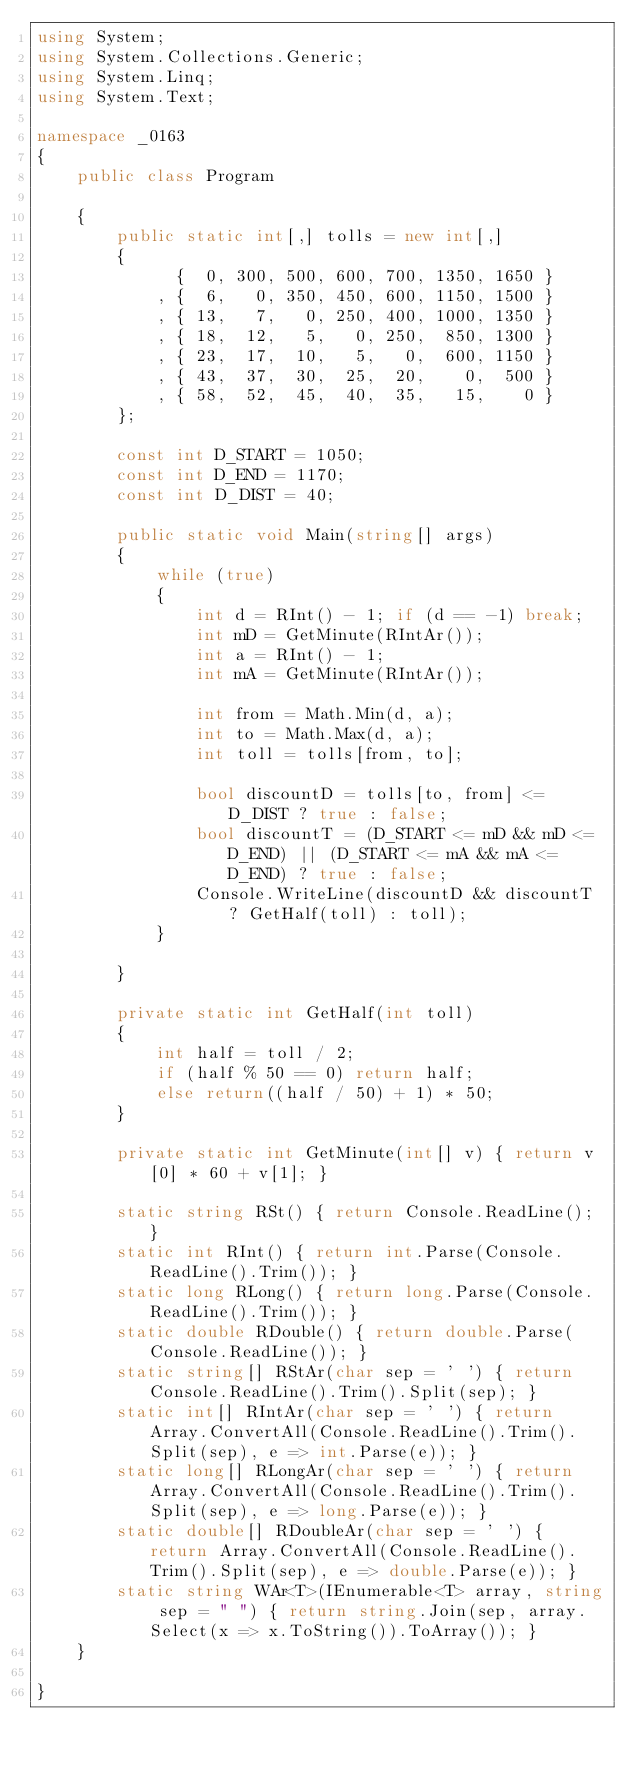<code> <loc_0><loc_0><loc_500><loc_500><_C#_>using System;
using System.Collections.Generic;
using System.Linq;
using System.Text;

namespace _0163
{
    public class Program

    {
        public static int[,] tolls = new int[,]
        {
              {  0, 300, 500, 600, 700, 1350, 1650 }
            , {  6,   0, 350, 450, 600, 1150, 1500 }
            , { 13,   7,   0, 250, 400, 1000, 1350 }
            , { 18,  12,   5,   0, 250,  850, 1300 }
            , { 23,  17,  10,   5,   0,  600, 1150 }
            , { 43,  37,  30,  25,  20,    0,  500 }
            , { 58,  52,  45,  40,  35,   15,    0 }
        };

        const int D_START = 1050;
        const int D_END = 1170;
        const int D_DIST = 40;

        public static void Main(string[] args)
        {
            while (true)
            {
                int d = RInt() - 1; if (d == -1) break;
                int mD = GetMinute(RIntAr());
                int a = RInt() - 1;
                int mA = GetMinute(RIntAr());

                int from = Math.Min(d, a);
                int to = Math.Max(d, a);
                int toll = tolls[from, to];

                bool discountD = tolls[to, from] <= D_DIST ? true : false;
                bool discountT = (D_START <= mD && mD <= D_END) || (D_START <= mA && mA <= D_END) ? true : false;
                Console.WriteLine(discountD && discountT ? GetHalf(toll) : toll);
            }

        }

        private static int GetHalf(int toll)
        {
            int half = toll / 2;
            if (half % 50 == 0) return half;
            else return((half / 50) + 1) * 50;
        }

        private static int GetMinute(int[] v) { return v[0] * 60 + v[1]; }

        static string RSt() { return Console.ReadLine(); }
        static int RInt() { return int.Parse(Console.ReadLine().Trim()); }
        static long RLong() { return long.Parse(Console.ReadLine().Trim()); }
        static double RDouble() { return double.Parse(Console.ReadLine()); }
        static string[] RStAr(char sep = ' ') { return Console.ReadLine().Trim().Split(sep); }
        static int[] RIntAr(char sep = ' ') { return Array.ConvertAll(Console.ReadLine().Trim().Split(sep), e => int.Parse(e)); }
        static long[] RLongAr(char sep = ' ') { return Array.ConvertAll(Console.ReadLine().Trim().Split(sep), e => long.Parse(e)); }
        static double[] RDoubleAr(char sep = ' ') { return Array.ConvertAll(Console.ReadLine().Trim().Split(sep), e => double.Parse(e)); }
        static string WAr<T>(IEnumerable<T> array, string sep = " ") { return string.Join(sep, array.Select(x => x.ToString()).ToArray()); }
    }

}

</code> 